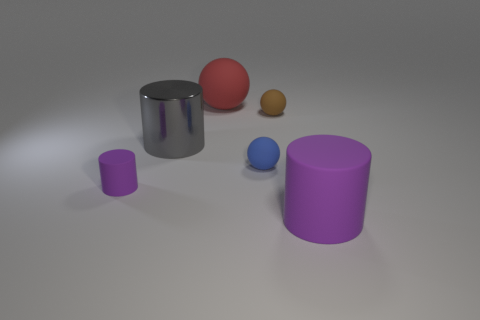Add 4 large blue shiny balls. How many objects exist? 10 Add 5 big metal blocks. How many big metal blocks exist? 5 Subtract 0 brown cubes. How many objects are left? 6 Subtract all metallic balls. Subtract all big metal cylinders. How many objects are left? 5 Add 6 brown spheres. How many brown spheres are left? 7 